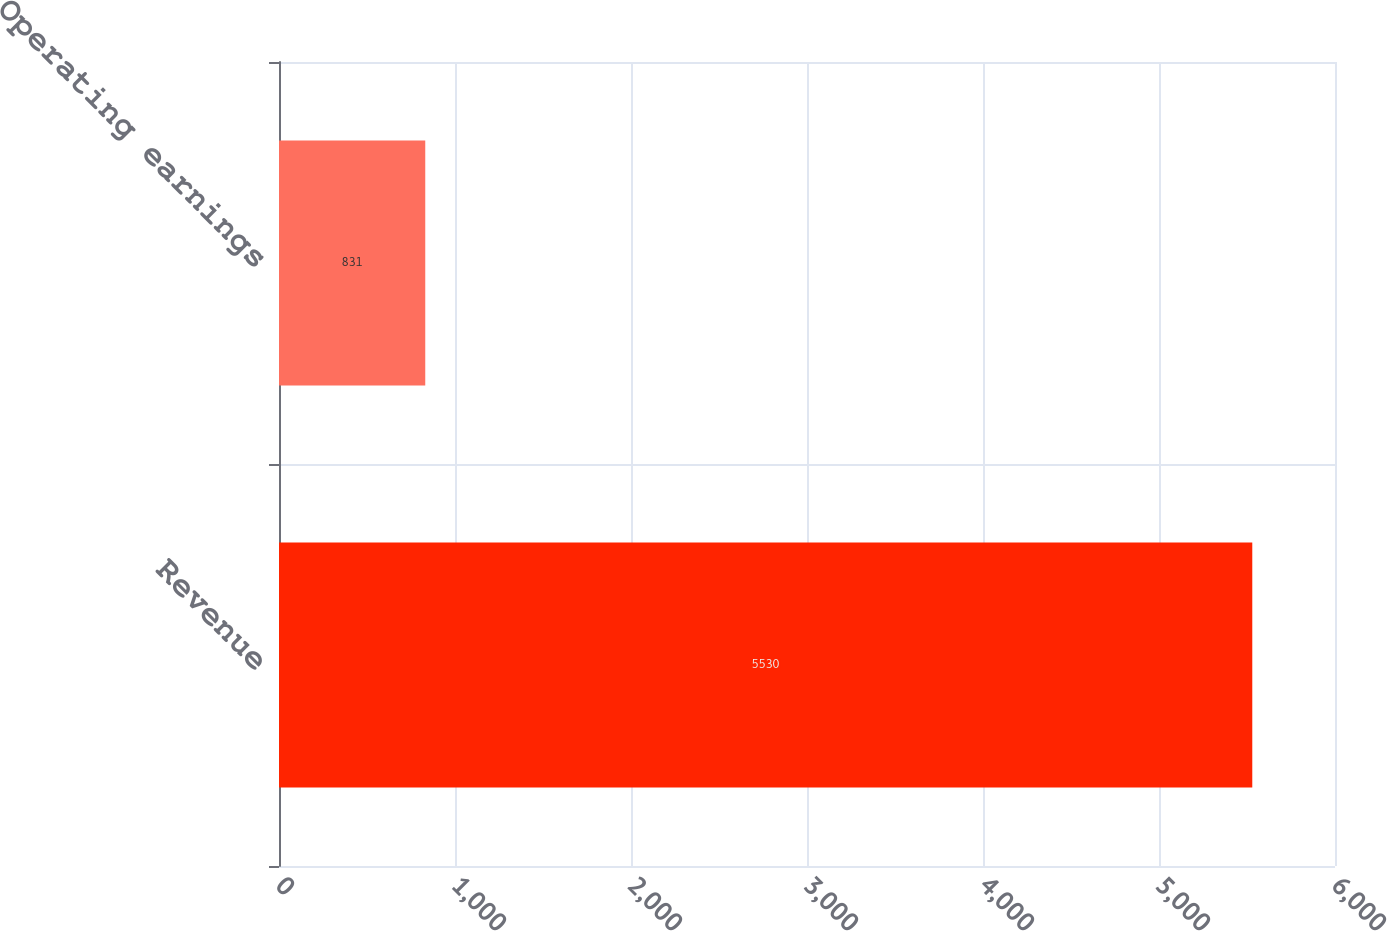Convert chart to OTSL. <chart><loc_0><loc_0><loc_500><loc_500><bar_chart><fcel>Revenue<fcel>Operating earnings<nl><fcel>5530<fcel>831<nl></chart> 